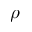<formula> <loc_0><loc_0><loc_500><loc_500>\rho</formula> 